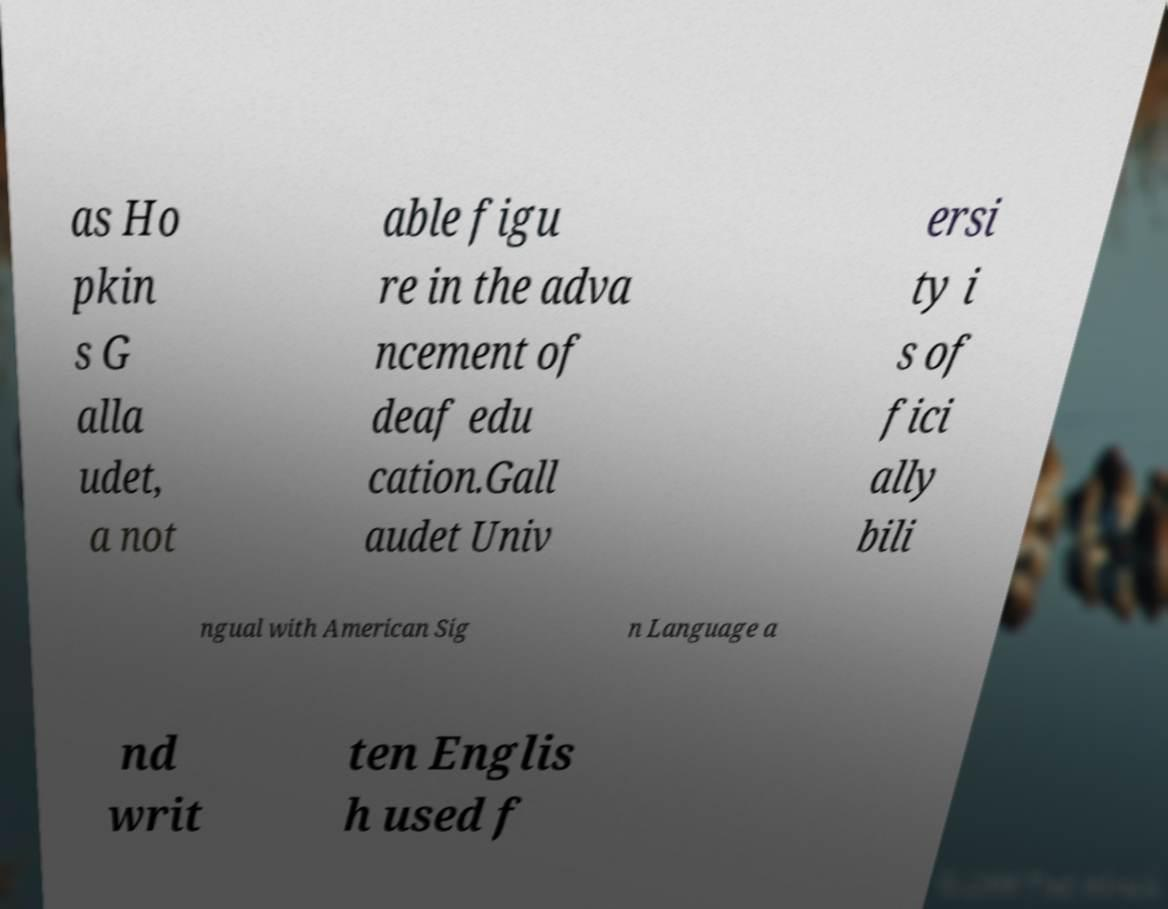Could you extract and type out the text from this image? as Ho pkin s G alla udet, a not able figu re in the adva ncement of deaf edu cation.Gall audet Univ ersi ty i s of fici ally bili ngual with American Sig n Language a nd writ ten Englis h used f 